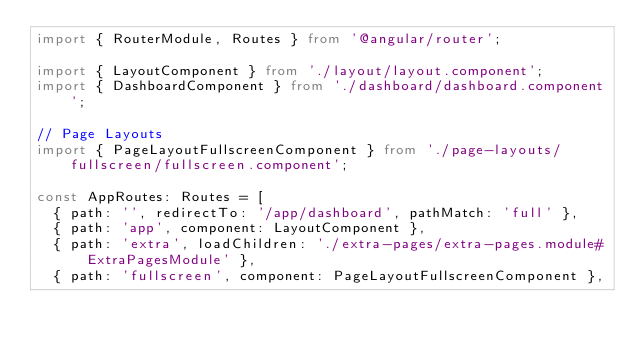<code> <loc_0><loc_0><loc_500><loc_500><_TypeScript_>import { RouterModule, Routes } from '@angular/router';

import { LayoutComponent } from './layout/layout.component';
import { DashboardComponent } from './dashboard/dashboard.component';

// Page Layouts
import { PageLayoutFullscreenComponent } from './page-layouts/fullscreen/fullscreen.component';

const AppRoutes: Routes = [
  { path: '', redirectTo: '/app/dashboard', pathMatch: 'full' },
  { path: 'app', component: LayoutComponent },
  { path: 'extra', loadChildren: './extra-pages/extra-pages.module#ExtraPagesModule' },
  { path: 'fullscreen', component: PageLayoutFullscreenComponent },</code> 